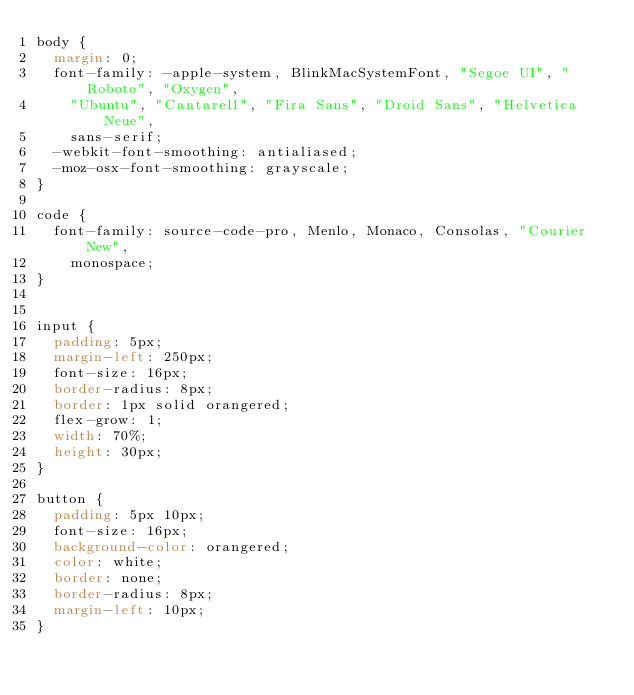Convert code to text. <code><loc_0><loc_0><loc_500><loc_500><_CSS_>body {
  margin: 0;
  font-family: -apple-system, BlinkMacSystemFont, "Segoe UI", "Roboto", "Oxygen",
    "Ubuntu", "Cantarell", "Fira Sans", "Droid Sans", "Helvetica Neue",
    sans-serif;
  -webkit-font-smoothing: antialiased;
  -moz-osx-font-smoothing: grayscale;
}

code {
  font-family: source-code-pro, Menlo, Monaco, Consolas, "Courier New",
    monospace;
}


input {
  padding: 5px;
  margin-left: 250px;
  font-size: 16px;
  border-radius: 8px;
  border: 1px solid orangered;
  flex-grow: 1;
  width: 70%;
  height: 30px;
}

button {
  padding: 5px 10px;
  font-size: 16px;
  background-color: orangered;
  color: white;
  border: none;
  border-radius: 8px;
  margin-left: 10px;
}</code> 